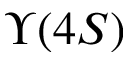<formula> <loc_0><loc_0><loc_500><loc_500>\Upsilon ( 4 S )</formula> 